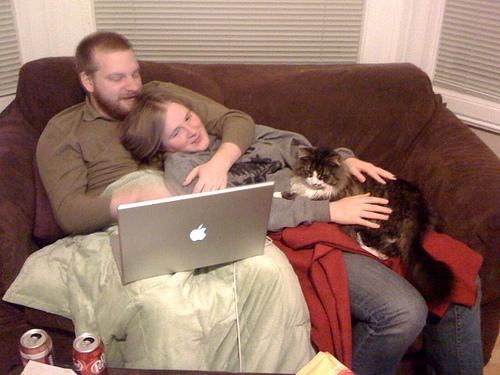Question: what brand is the laptop?
Choices:
A. Asus.
B. Microsoft.
C. Toshiba.
D. Apple.
Answer with the letter. Answer: D Question: how many cans of sodas on the table?
Choices:
A. 1.
B. 5.
C. 2.
D. 7.
Answer with the letter. Answer: C Question: what color are the cans of sodas?
Choices:
A. Burgundy.
B. Teal.
C. Purple.
D. Neon.
Answer with the letter. Answer: A Question: what kind of pants is the woman wearing?
Choices:
A. Jeans.
B. Khakis.
C. Cargo pants.
D. Slacks.
Answer with the letter. Answer: A Question: what is covering the window?
Choices:
A. Blinds.
B. Drapes.
C. Curtains.
D. Sheets.
Answer with the letter. Answer: A 